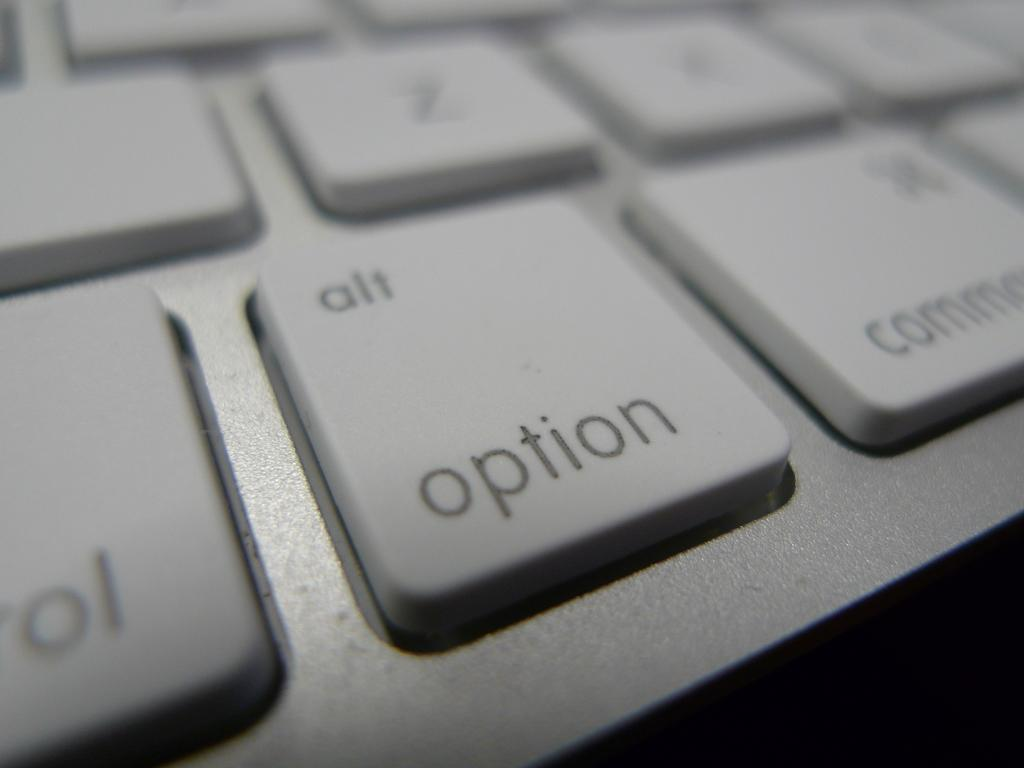<image>
Give a short and clear explanation of the subsequent image. A white key for the alt option is zoomed in on. 